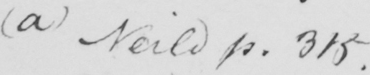Can you tell me what this handwritten text says? ( a )  Neild p . 315 